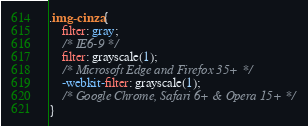<code> <loc_0><loc_0><loc_500><loc_500><_CSS_>.img-cinza{
    filter: gray;
    /* IE6-9 */
    filter: grayscale(1);
    /* Microsoft Edge and Firefox 35+ */
    -webkit-filter: grayscale(1);
    /* Google Chrome, Safari 6+ & Opera 15+ */
}
</code> 